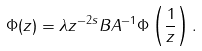<formula> <loc_0><loc_0><loc_500><loc_500>\Phi ( z ) = \lambda z ^ { - 2 s } B A ^ { - 1 } \Phi \left ( \frac { 1 } { z } \right ) .</formula> 